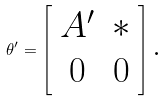Convert formula to latex. <formula><loc_0><loc_0><loc_500><loc_500>\theta ^ { \prime } = \left [ \begin{array} { c c } A ^ { \prime } & \ast \\ 0 & 0 \end{array} \right ] \text {.}</formula> 